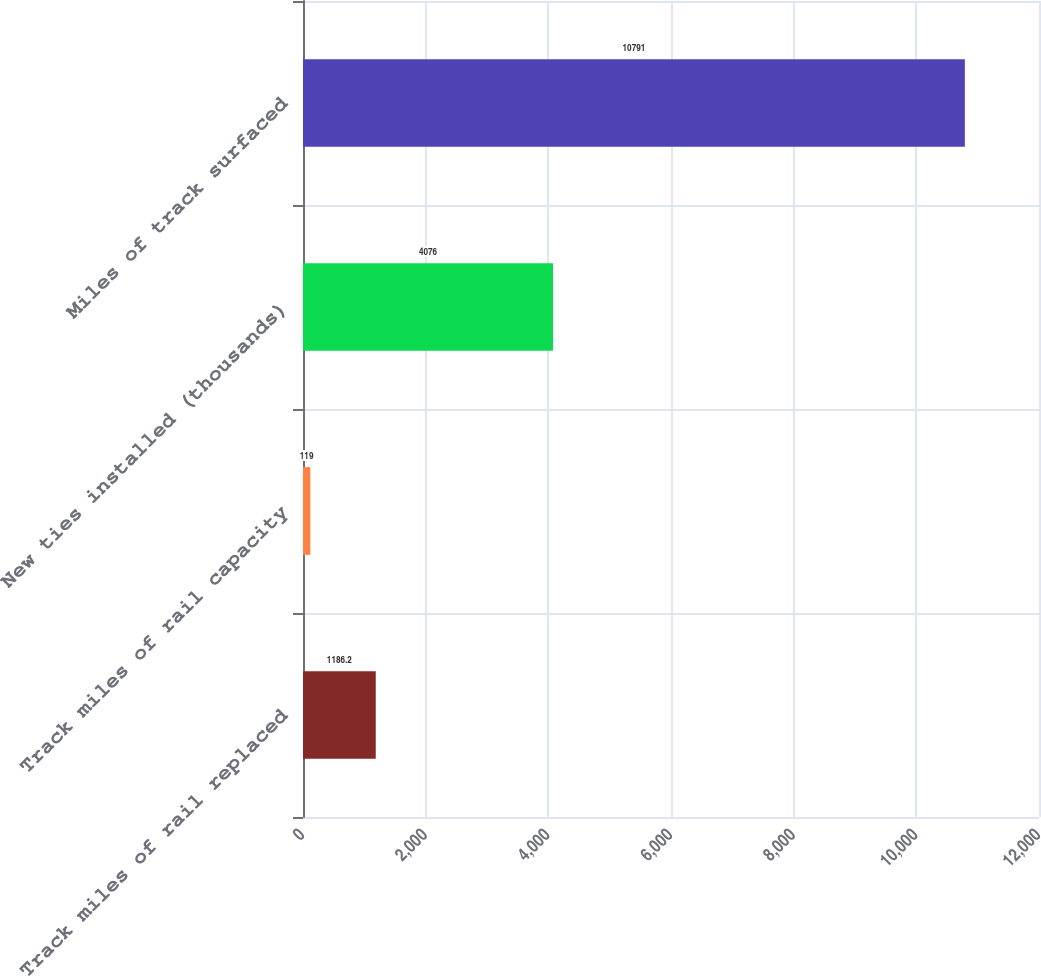<chart> <loc_0><loc_0><loc_500><loc_500><bar_chart><fcel>Track miles of rail replaced<fcel>Track miles of rail capacity<fcel>New ties installed (thousands)<fcel>Miles of track surfaced<nl><fcel>1186.2<fcel>119<fcel>4076<fcel>10791<nl></chart> 